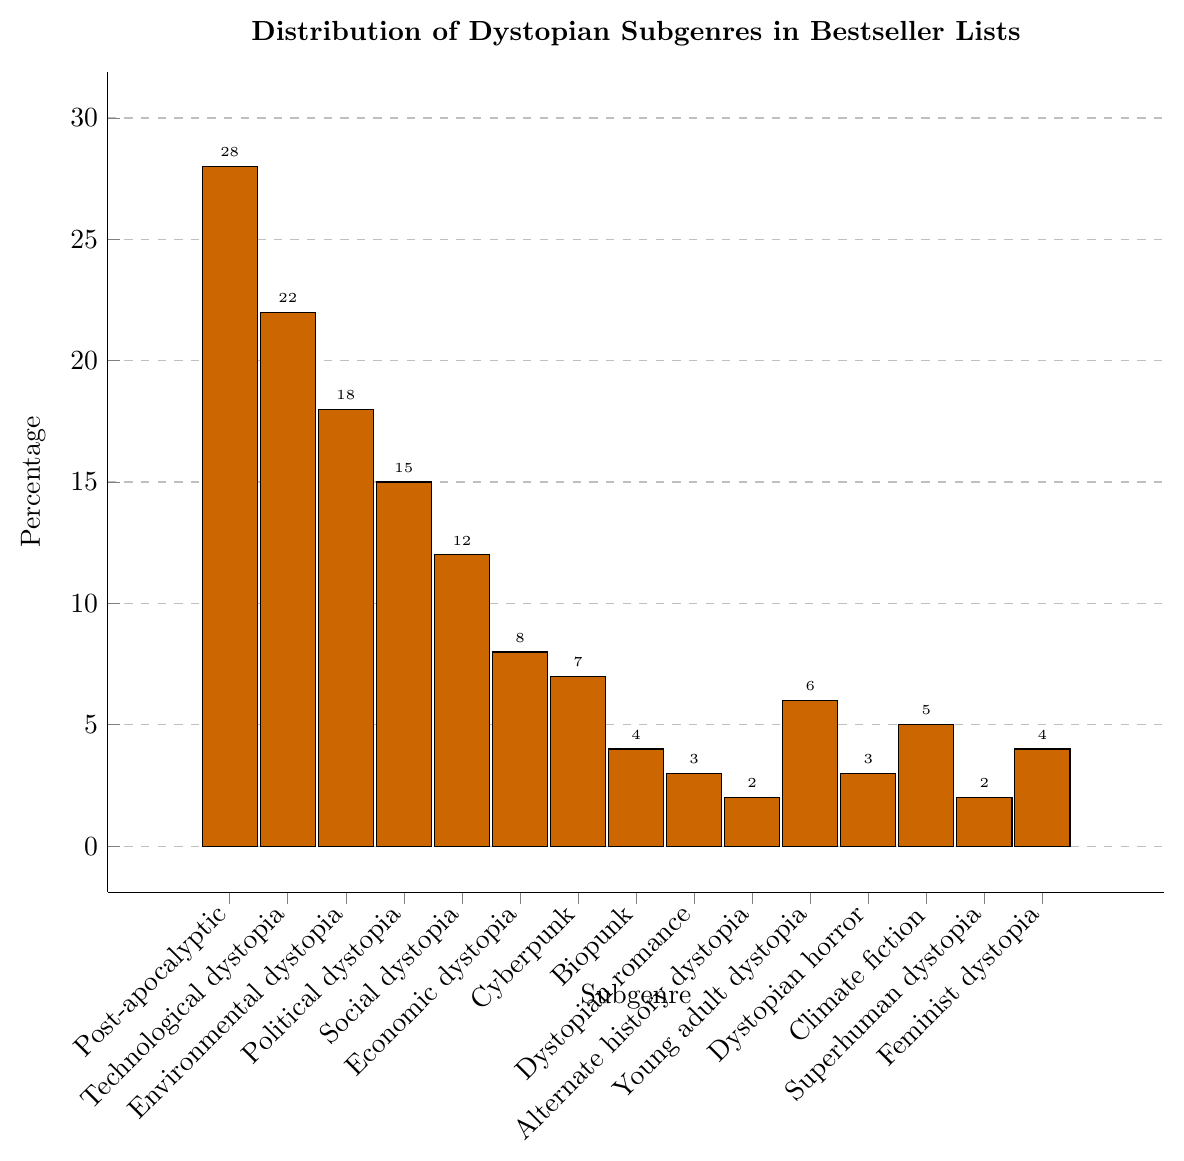What's the most common dystopian subgenre in the bestseller lists? By observing the bar chart, it is clear that the "Post-apocalyptic" subgenre has the highest bar, indicating it has the highest percentage.
Answer: Post-apocalyptic How much higher is the percentage of "Post-apocalyptic" compared to "Cyberpunk"? The percentage for "Post-apocalyptic" is 28%, and for "Cyberpunk" it is 7%. The difference is calculated as 28% - 7% = 21%.
Answer: 21% Which subgenres have lower percentages than "Social dystopia"? From the chart, any subgenre with a percentage less than 12% falls under this category. These subgenres are Economic dystopia (8%), Cyberpunk (7%), Biopunk (4%), Dystopian romance (3%), Alternate history dystopia (2%), Young adult dystopia (6%), Dystopian horror (3%), Climate fiction (5%), Superhuman dystopia (2%), and Feminist dystopia (4%).
Answer: Economic dystopia, Cyberpunk, Biopunk, Dystopian romance, Alternate history dystopia, Young adult dystopia, Dystopian horror, Climate fiction, Superhuman dystopia, Feminist dystopia What's the combined percentage of "Economic dystopia" and "Social dystopia"? To find the combined percentage, add the percentages of "Economic dystopia" (8%) and "Social dystopia" (12%): 8% + 12% = 20%.
Answer: 20% What is the least represented subgenre in the bestseller lists? The smallest bar in the chart corresponds to the "Alternate history dystopia" subgenre, which has a percentage of 2%.
Answer: Alternate history dystopia Is "Environmental dystopia" more popular than "Political dystopia"? The bar representing "Environmental dystopia" is taller than that for "Political dystopia". "Environmental dystopia" is at 18%, while "Political dystopia" is at 15%.
Answer: Yes How many subgenres have a percentage of 5% or greater? From the chart, count the bars that have a height corresponding to 5% or greater: Post-apocalyptic (28%), Technological dystopia (22%), Environmental dystopia (18%), Political dystopia (15%), Social dystopia (12%), Economic dystopia (8%), Cyberpunk (7%), Young adult dystopia (6%), and Climate fiction (5%). There are 9 such subgenres.
Answer: 9 Which subgenre has a percentage of 4% and shares the same percentage as another subgenre? "Biopunk" and "Feminist dystopia" both have percentages of 4% as indicated by their similar bar heights.
Answer: Biopunk, Feminist dystopia 